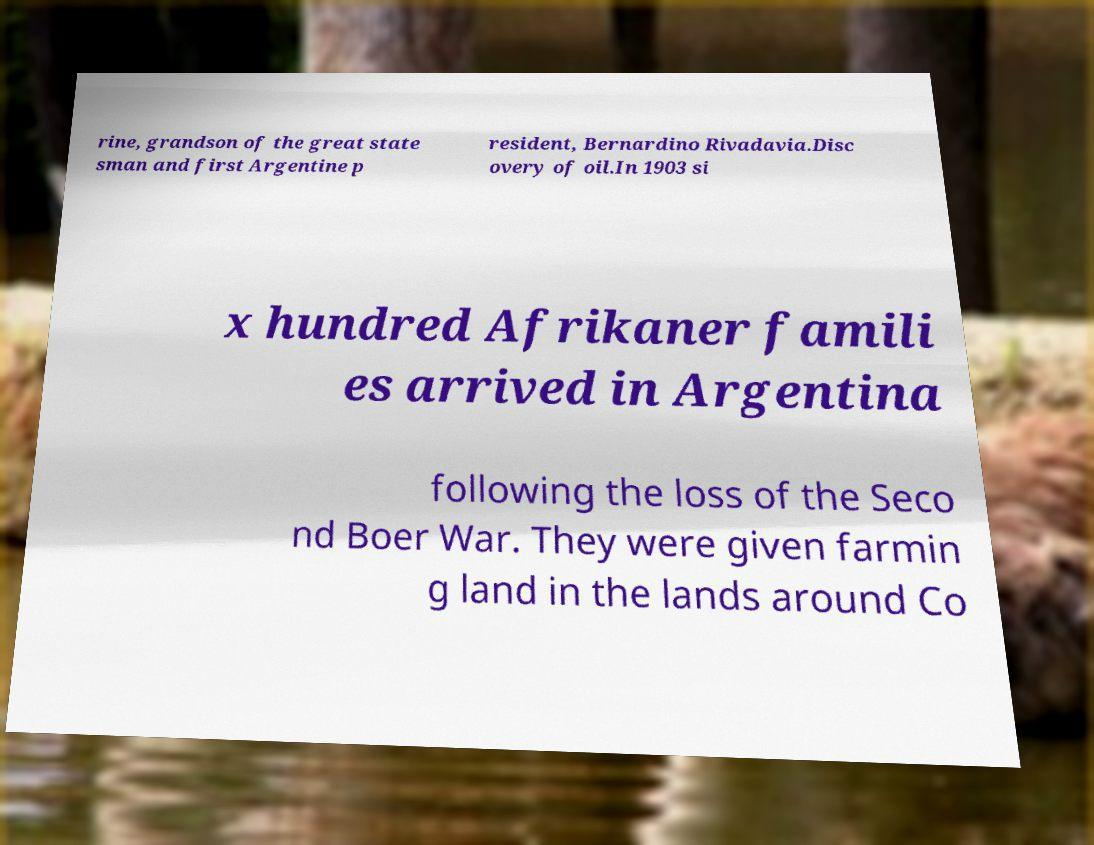What messages or text are displayed in this image? I need them in a readable, typed format. rine, grandson of the great state sman and first Argentine p resident, Bernardino Rivadavia.Disc overy of oil.In 1903 si x hundred Afrikaner famili es arrived in Argentina following the loss of the Seco nd Boer War. They were given farmin g land in the lands around Co 